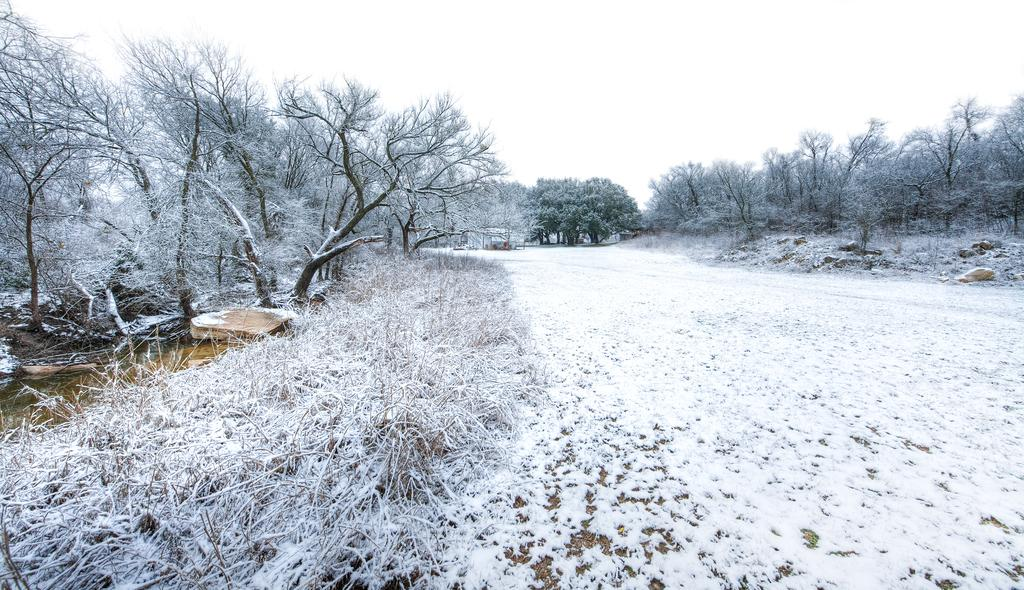What is covering the ground in the image? There is snow on the ground in the image. What type of vegetation can be seen in the image? There are trees in the image. What is visible at the top of the image? The sky is visible at the top of the image. Where are the apples and jam located in the image? There are no apples or jam present in the image. How does the snow move around in the image? The snow does not move around in the image; it is stationary on the ground. 